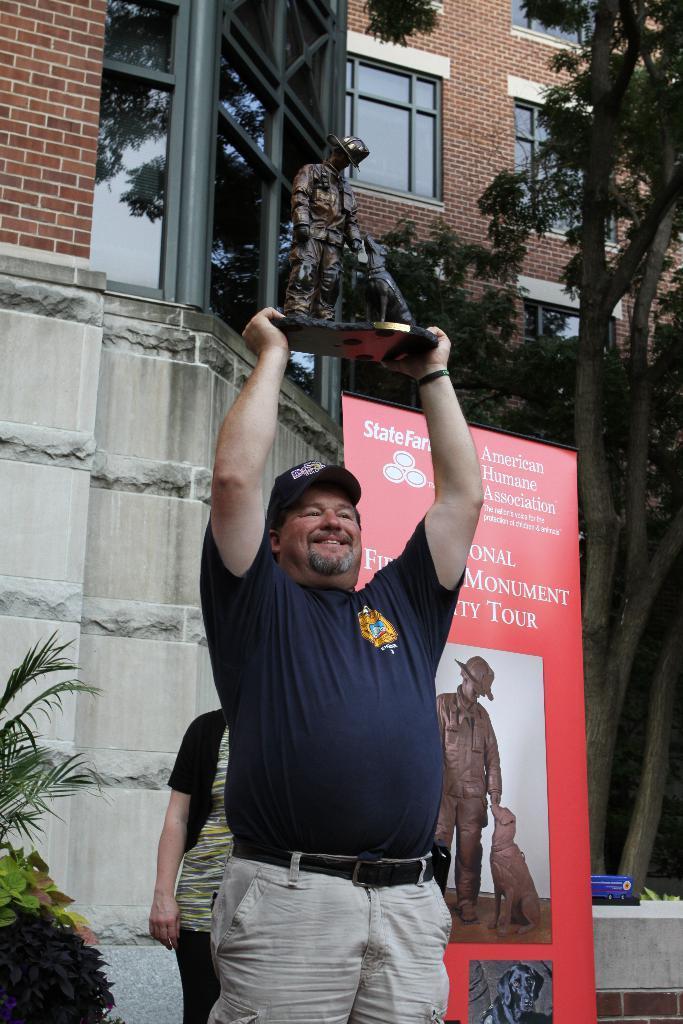How would you summarize this image in a sentence or two? In this picture I can see two persons standing. I can see a man standing and smiling by holding an object. There is a banner. There are plants, trees, and in the background there is a building. 